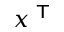<formula> <loc_0><loc_0><loc_500><loc_500>x ^ { T }</formula> 